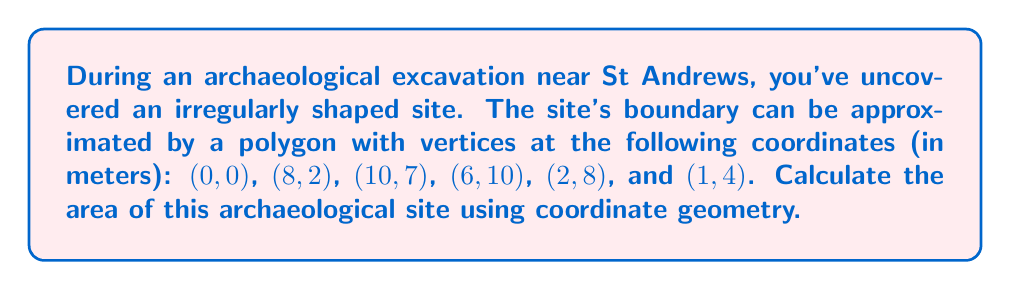Solve this math problem. To calculate the area of this irregular polygon, we can use the Shoelace formula (also known as the surveyor's formula). This method involves the following steps:

1) List the coordinates in order, repeating the first coordinate at the end:
   $(x_1,y_1)$, $(x_2,y_2)$, ..., $(x_n,y_n)$, $(x_1,y_1)$

2) Apply the formula:
   $$A = \frac{1}{2}|(x_1y_2 + x_2y_3 + ... + x_ny_1) - (y_1x_2 + y_2x_3 + ... + y_nx_1)|$$

3) Let's apply this to our coordinates:
   (0,0), (8,2), (10,7), (6,10), (2,8), (1,4), (0,0)

4) Calculate the first part of the formula:
   $$(0 \cdot 2) + (8 \cdot 7) + (10 \cdot 10) + (6 \cdot 8) + (2 \cdot 4) + (1 \cdot 0) = 0 + 56 + 100 + 48 + 8 + 0 = 212$$

5) Calculate the second part of the formula:
   $$(0 \cdot 8) + (2 \cdot 10) + (7 \cdot 6) + (10 \cdot 2) + (8 \cdot 1) + (4 \cdot 0) = 0 + 20 + 42 + 20 + 8 + 0 = 90$$

6) Subtract and take the absolute value:
   $|212 - 90| = 122$

7) Multiply by 1/2:
   $$\frac{1}{2} \cdot 122 = 61$$

Therefore, the area of the archaeological site is 61 square meters.
Answer: 61 m² 